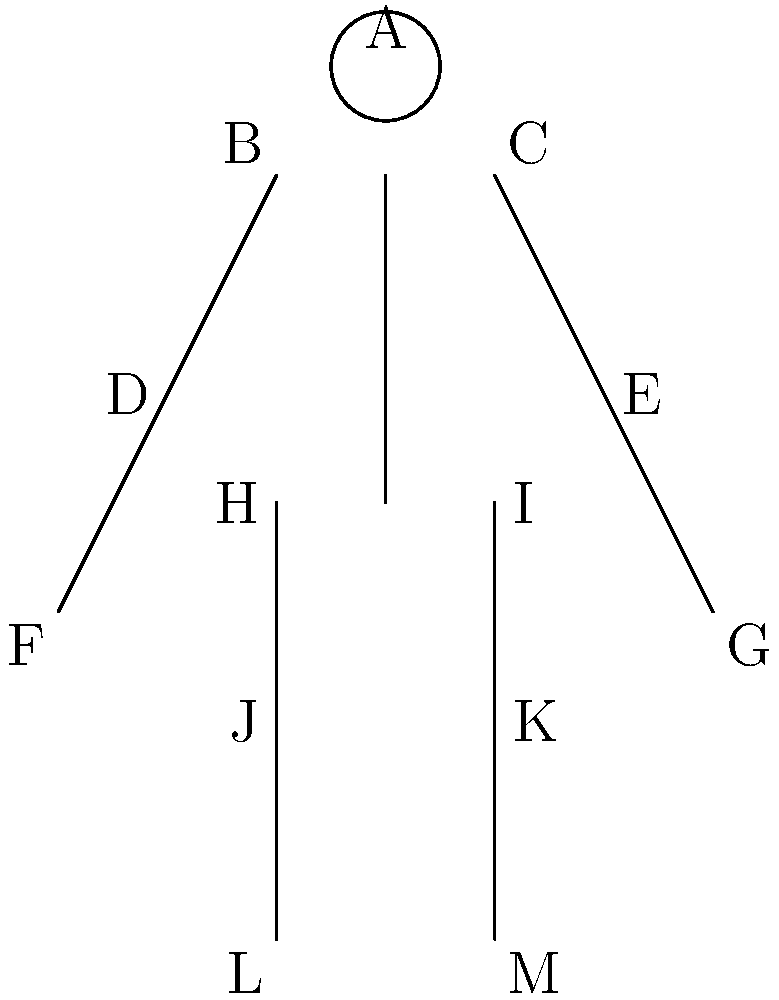Given the stick figure representation of a humanoid robot, which joint angles would be most critical for estimating the robot's overall pose, assuming a standard 6-degree-of-freedom (6-DoF) pose estimation problem? To estimate the pose of a humanoid robot using a 6-DoF approach, we need to consider the following steps:

1. Understand 6-DoF pose estimation:
   - 3 degrees for position (x, y, z)
   - 3 degrees for orientation (roll, pitch, yaw)

2. Identify key body parts for pose estimation:
   - The torso is typically considered the robot's main body
   - Head position can provide additional orientation information

3. Analyze the stick figure:
   - The line from point H to I represents the hip line (part of the torso)
   - The line from the midpoint of HI to point A represents the spine and head

4. Determine critical joint angles:
   a) Hip joints (H and I): These define the base of the torso
   b) Shoulder joints (B and C): These define the top of the torso
   c) Neck joint (between neck and head): This provides head orientation

5. Reasoning for selection:
   - Hip and shoulder joints give us the torso's orientation (roll and pitch)
   - The neck joint, combined with torso orientation, provides yaw information
   - The positions of these joints also help determine the overall position of the robot

6. Other joints (e.g., elbows, knees) are less critical for overall pose estimation, as they mainly affect limb positions rather than the core body pose.

Therefore, the most critical joint angles for estimating the robot's overall pose are those at the hips, shoulders, and neck.
Answer: Hip, shoulder, and neck joint angles 